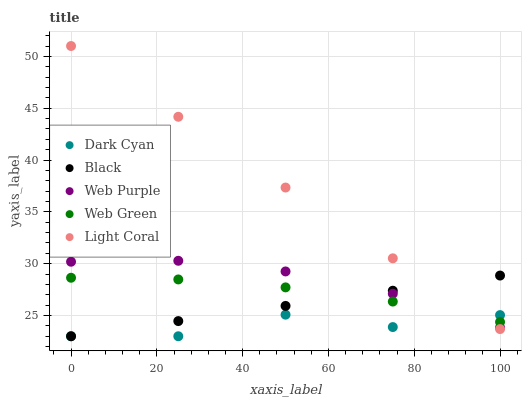Does Dark Cyan have the minimum area under the curve?
Answer yes or no. Yes. Does Light Coral have the maximum area under the curve?
Answer yes or no. Yes. Does Web Purple have the minimum area under the curve?
Answer yes or no. No. Does Web Purple have the maximum area under the curve?
Answer yes or no. No. Is Light Coral the smoothest?
Answer yes or no. Yes. Is Dark Cyan the roughest?
Answer yes or no. Yes. Is Web Purple the smoothest?
Answer yes or no. No. Is Web Purple the roughest?
Answer yes or no. No. Does Dark Cyan have the lowest value?
Answer yes or no. Yes. Does Light Coral have the lowest value?
Answer yes or no. No. Does Light Coral have the highest value?
Answer yes or no. Yes. Does Web Purple have the highest value?
Answer yes or no. No. Does Dark Cyan intersect Black?
Answer yes or no. Yes. Is Dark Cyan less than Black?
Answer yes or no. No. Is Dark Cyan greater than Black?
Answer yes or no. No. 